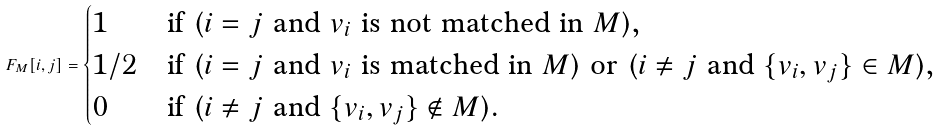Convert formula to latex. <formula><loc_0><loc_0><loc_500><loc_500>F _ { M } [ i , j ] = \begin{cases} 1 & \text {if ($i=j$ and $v_{i}$ is not matched in $M$),} \\ 1 / 2 & \text {if ($i=j$ and $v_{i}$ is matched in $M$) or ($i \neq j$ and $\{v_{i}, v_{j}\} \in M$),} \\ 0 & \text {if ($i \neq j$ and $\{v_{i}, v_{j}\} \notin M$).} \end{cases}</formula> 